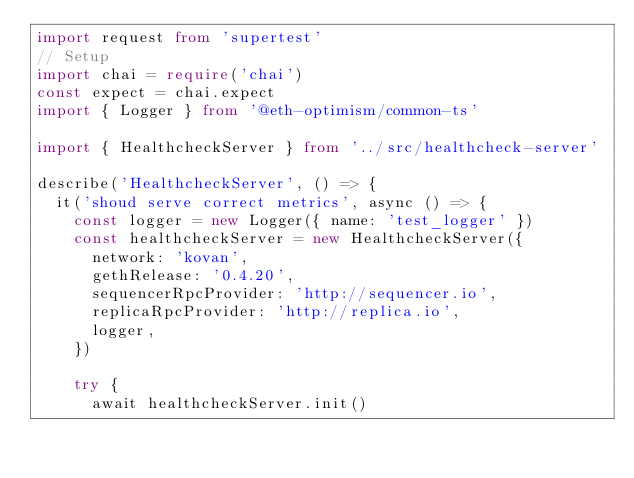<code> <loc_0><loc_0><loc_500><loc_500><_TypeScript_>import request from 'supertest'
// Setup
import chai = require('chai')
const expect = chai.expect
import { Logger } from '@eth-optimism/common-ts'

import { HealthcheckServer } from '../src/healthcheck-server'

describe('HealthcheckServer', () => {
  it('shoud serve correct metrics', async () => {
    const logger = new Logger({ name: 'test_logger' })
    const healthcheckServer = new HealthcheckServer({
      network: 'kovan',
      gethRelease: '0.4.20',
      sequencerRpcProvider: 'http://sequencer.io',
      replicaRpcProvider: 'http://replica.io',
      logger,
    })

    try {
      await healthcheckServer.init()</code> 